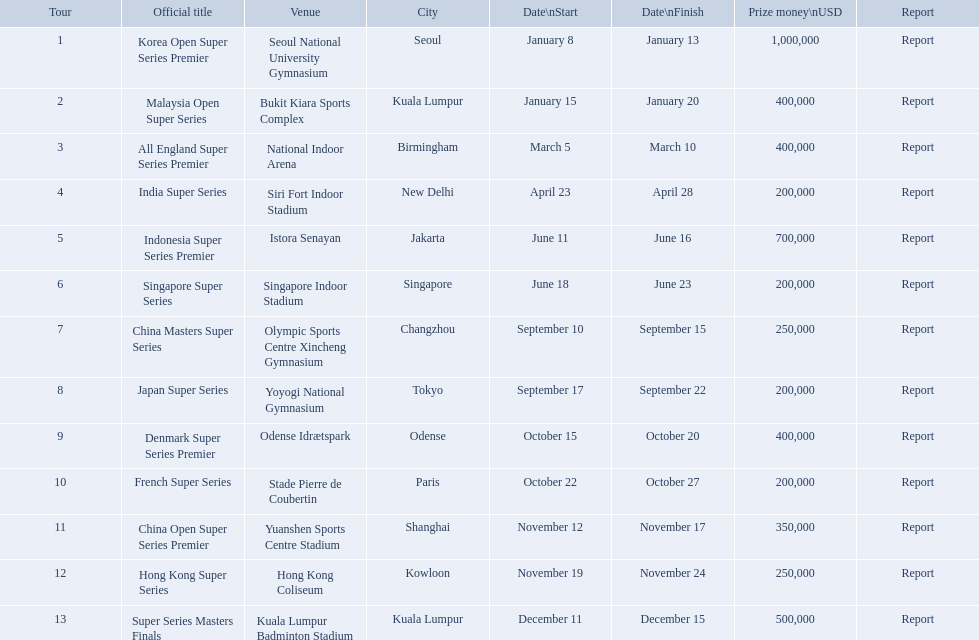What are all the titles? Korea Open Super Series Premier, Malaysia Open Super Series, All England Super Series Premier, India Super Series, Indonesia Super Series Premier, Singapore Super Series, China Masters Super Series, Japan Super Series, Denmark Super Series Premier, French Super Series, China Open Super Series Premier, Hong Kong Super Series, Super Series Masters Finals. When did they take place? January 8, January 15, March 5, April 23, June 11, June 18, September 10, September 17, October 15, October 22, November 12, November 19, December 11. Which title took place in december? Super Series Masters Finals. What are all the trips? Korea Open Super Series Premier, Malaysia Open Super Series, All England Super Series Premier, India Super Series, Indonesia Super Series Premier, Singapore Super Series, China Masters Super Series, Japan Super Series, Denmark Super Series Premier, French Super Series, China Open Super Series Premier, Hong Kong Super Series, Super Series Masters Finals. What were the initiation dates of these trips? January 8, January 15, March 5, April 23, June 11, June 18, September 10, September 17, October 15, October 22, November 12, November 19, December 11. Of these, which is in december? December 11. Which trip started on this date? Super Series Masters Finals. What are all the designations? Korea Open Super Series Premier, Malaysia Open Super Series, All England Super Series Premier, India Super Series, Indonesia Super Series Premier, Singapore Super Series, China Masters Super Series, Japan Super Series, Denmark Super Series Premier, French Super Series, China Open Super Series Premier, Hong Kong Super Series, Super Series Masters Finals. When did they occur? January 8, January 15, March 5, April 23, June 11, June 18, September 10, September 17, October 15, October 22, November 12, November 19, December 11. Which designation happened in december? Super Series Masters Finals. What are the complete list of titles? Korea Open Super Series Premier, Malaysia Open Super Series, All England Super Series Premier, India Super Series, Indonesia Super Series Premier, Singapore Super Series, China Masters Super Series, Japan Super Series, Denmark Super Series Premier, French Super Series, China Open Super Series Premier, Hong Kong Super Series, Super Series Masters Finals. When were they held? January 8, January 15, March 5, April 23, June 11, June 18, September 10, September 17, October 15, October 22, November 12, November 19, December 11. Which title was conducted in december? Super Series Masters Finals. What are all the excursions? Korea Open Super Series Premier, Malaysia Open Super Series, All England Super Series Premier, India Super Series, Indonesia Super Series Premier, Singapore Super Series, China Masters Super Series, Japan Super Series, Denmark Super Series Premier, French Super Series, China Open Super Series Premier, Hong Kong Super Series, Super Series Masters Finals. What were the commencement dates of these excursions? January 8, January 15, March 5, April 23, June 11, June 18, September 10, September 17, October 15, October 22, November 12, November 19, December 11. Of these, which is in december? December 11. Which excursion began on this date? Super Series Masters Finals. What are every one of the titles? Korea Open Super Series Premier, Malaysia Open Super Series, All England Super Series Premier, India Super Series, Indonesia Super Series Premier, Singapore Super Series, China Masters Super Series, Japan Super Series, Denmark Super Series Premier, French Super Series, China Open Super Series Premier, Hong Kong Super Series, Super Series Masters Finals. When did they transpire? January 8, January 15, March 5, April 23, June 11, June 18, September 10, September 17, October 15, October 22, November 12, November 19, December 11. Which title transpired in december? Super Series Masters Finals. 